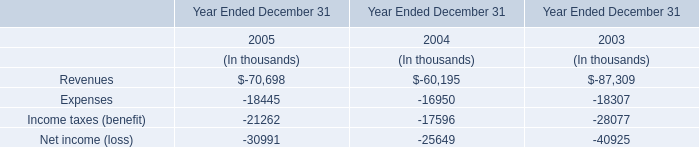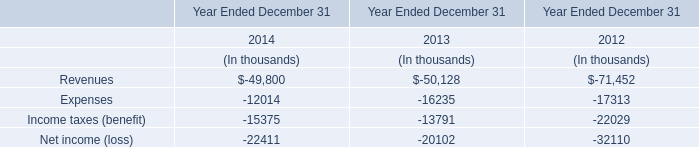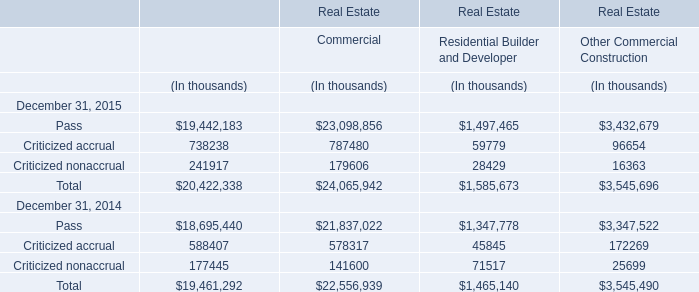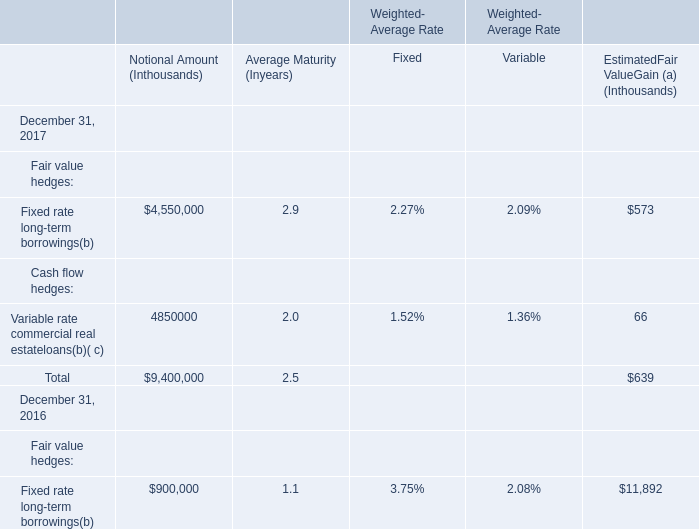What is the Estimated Fair Value Gain for all hedges as of December 31, 2017 ? (in thousand) 
Answer: 639. 